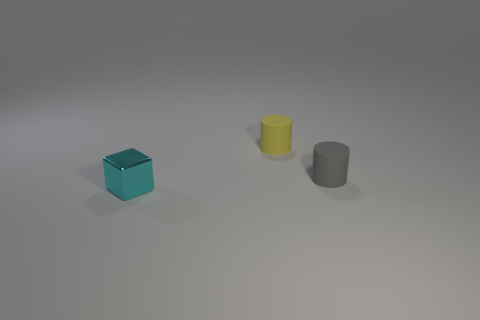Add 1 big cyan metallic blocks. How many objects exist? 4 Subtract all cylinders. How many objects are left? 1 Subtract all big green metal cubes. Subtract all tiny gray rubber cylinders. How many objects are left? 2 Add 3 tiny shiny blocks. How many tiny shiny blocks are left? 4 Add 2 green rubber cubes. How many green rubber cubes exist? 2 Subtract 0 purple cylinders. How many objects are left? 3 